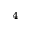Convert formula to latex. <formula><loc_0><loc_0><loc_500><loc_500>_ { 4 }</formula> 